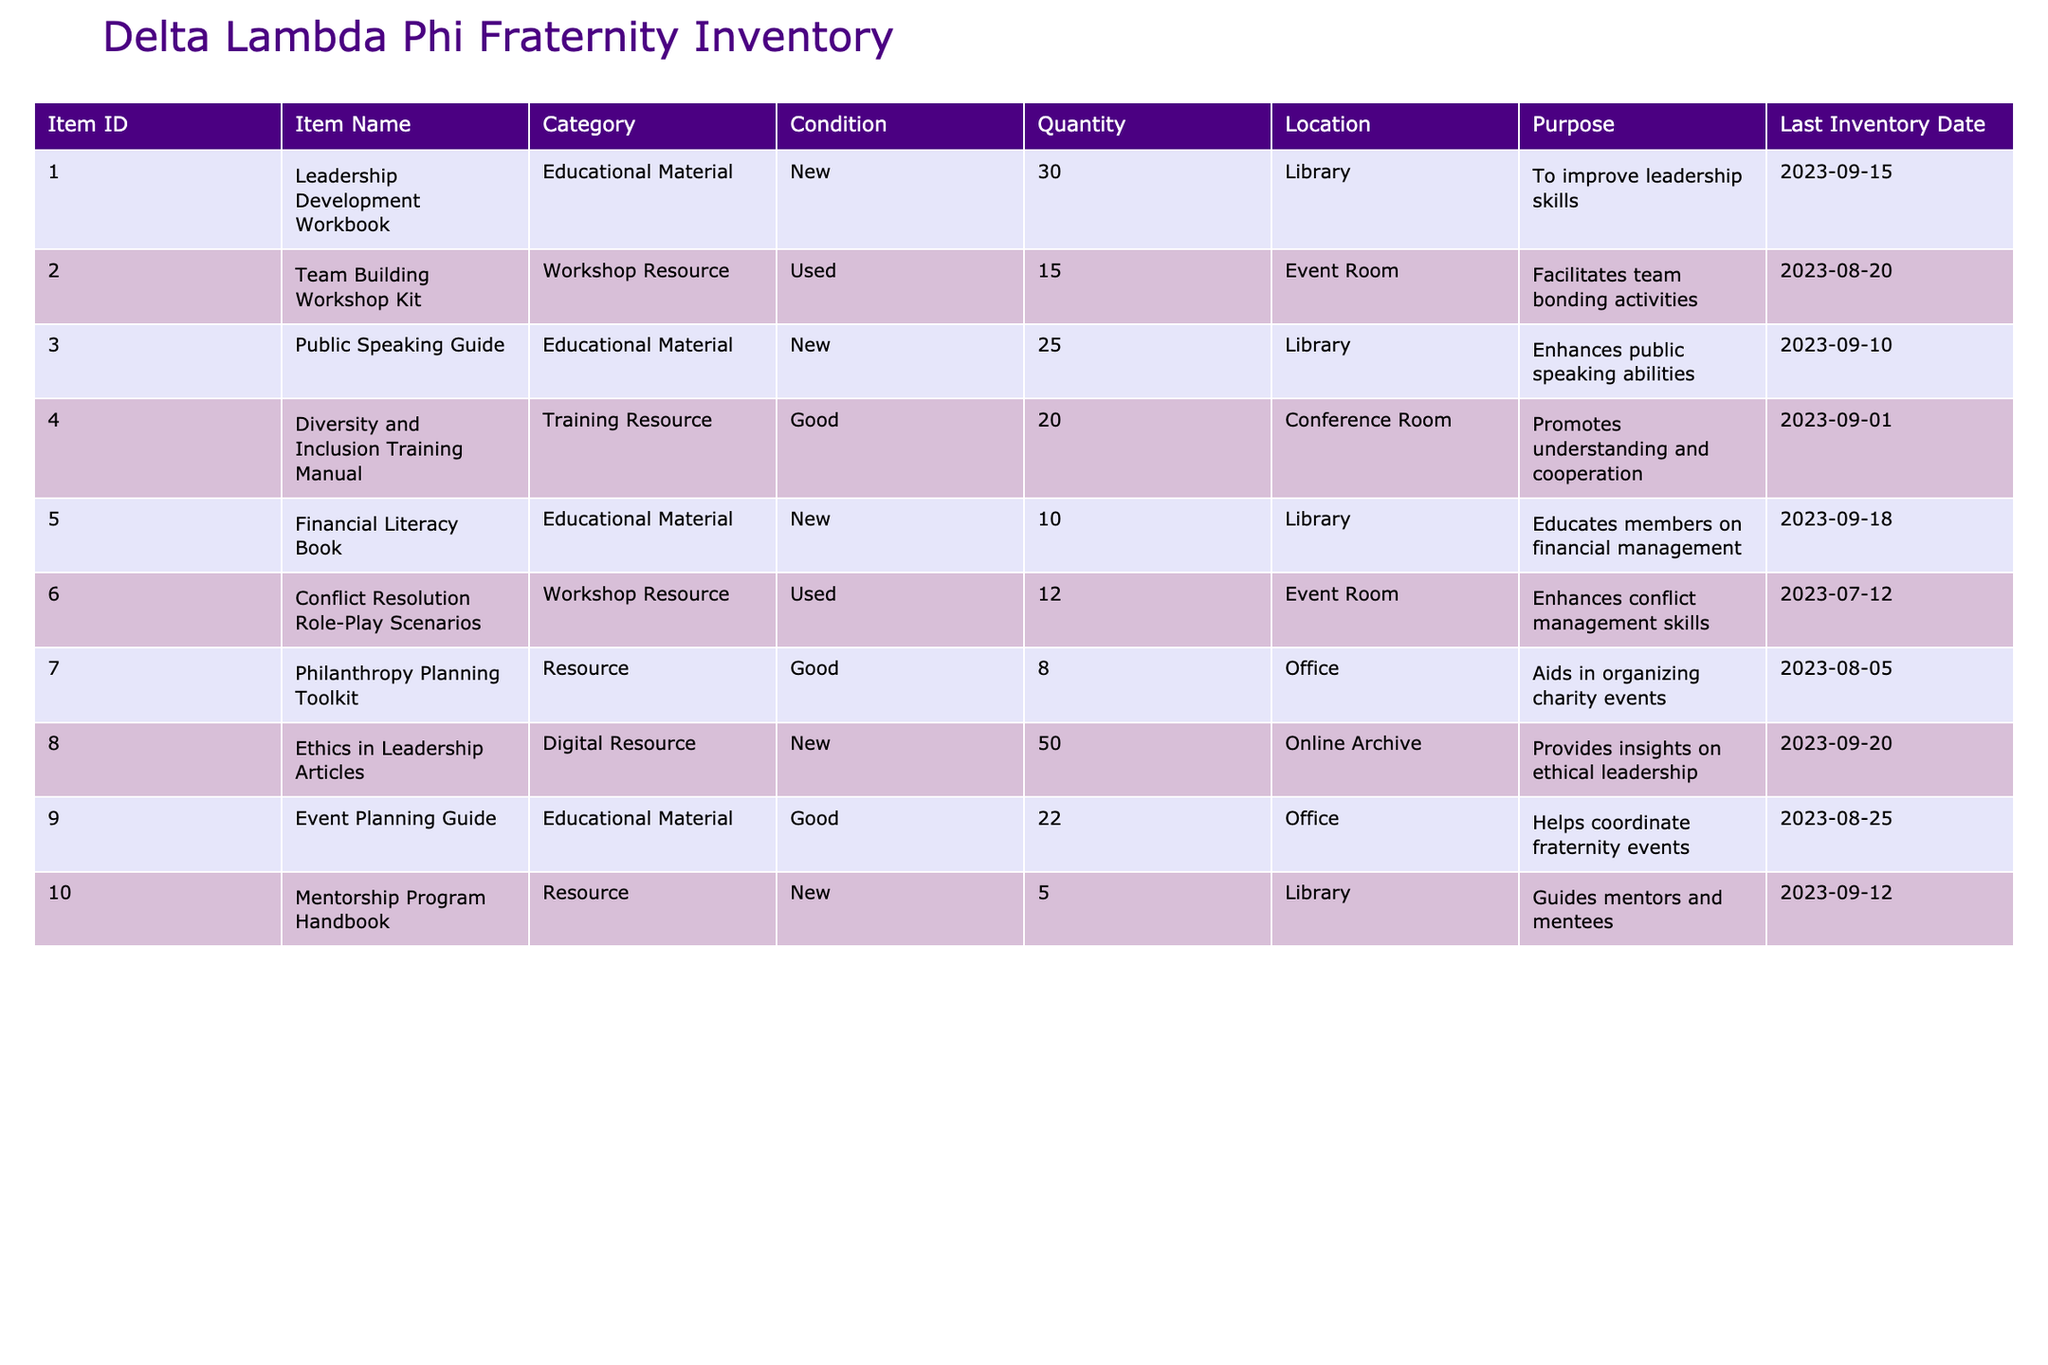What is the quantity of "Leadership Development Workbook" in inventory? The table indicates there are 30 units of the "Leadership Development Workbook" available in inventory as reflected in the Quantity column corresponding to the item ID 001.
Answer: 30 How many items are categorized as "Educational Material"? To find this, we count the items under the "Category" column that are labeled as "Educational Material." There are 4 such items: "Leadership Development Workbook," "Public Speaking Guide," "Financial Literacy Book," and "Event Planning Guide."
Answer: 4 What is the total quantity of workshop resources? We sum the quantities of only those items categorized as "Workshop Resource." There are two items: "Team Building Workshop Kit" with a quantity of 15 and "Conflict Resolution Role-Play Scenarios" with a quantity of 12. The total is 15 + 12 = 27.
Answer: 27 Is there any item categorized as "Digital Resource"? Yes, the table includes "Ethics in Leadership Articles" labeled as a "Digital Resource." This indicates that the statement is true.
Answer: Yes Which item has the best condition and what is its quantity? The item with the best condition is categorized as "New," which includes two items: "Leadership Development Workbook" with a quantity of 30 and "Public Speaking Guide" with a quantity of 25. The one with the highest quantity in this category is "Leadership Development Workbook" with 30 units.
Answer: Leadership Development Workbook, 30 What is the purpose of the "Diversity and Inclusion Training Manual"? The purpose for this item is listed as promoting understanding and cooperation, which aligns with its designation as a Training Resource.
Answer: To promote understanding and cooperation How many resources are stored in the "Library"? To find this, we look at the Location column for items stored in the "Library." The items located in the Library are: "Leadership Development Workbook," "Public Speaking Guide," "Financial Literacy Book," and "Mentorship Program Handbook," totaling 4 items.
Answer: 4 What is the average quantity of items in the "Office"? There are two items listed in the "Office": "Event Planning Guide" with a quantity of 22 and "Philanthropy Planning Toolkit" with a quantity of 8. The sum of these quantities is 22 + 8 = 30, and since there are two items, the average quantity is 30 / 2 = 15.
Answer: 15 How many items have been last inventoried after September 1, 2023? We check the Last Inventory Date column for all items, identifying those dated after September 1, 2023. Four items were last inventoried after this date: "Leadership Development Workbook," "Public Speaking Guide," "Financial Literacy Book," and "Ethics in Leadership Articles." Thus, there are 4 items.
Answer: 4 